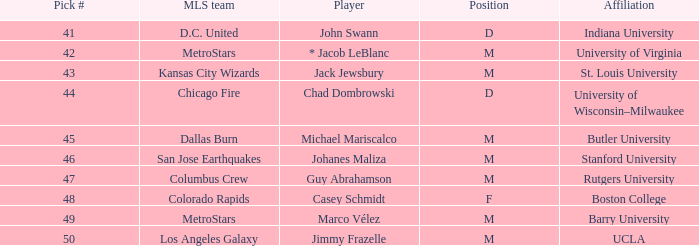Could you parse the entire table? {'header': ['Pick #', 'MLS team', 'Player', 'Position', 'Affiliation'], 'rows': [['41', 'D.C. United', 'John Swann', 'D', 'Indiana University'], ['42', 'MetroStars', '* Jacob LeBlanc', 'M', 'University of Virginia'], ['43', 'Kansas City Wizards', 'Jack Jewsbury', 'M', 'St. Louis University'], ['44', 'Chicago Fire', 'Chad Dombrowski', 'D', 'University of Wisconsin–Milwaukee'], ['45', 'Dallas Burn', 'Michael Mariscalco', 'M', 'Butler University'], ['46', 'San Jose Earthquakes', 'Johanes Maliza', 'M', 'Stanford University'], ['47', 'Columbus Crew', 'Guy Abrahamson', 'M', 'Rutgers University'], ['48', 'Colorado Rapids', 'Casey Schmidt', 'F', 'Boston College'], ['49', 'MetroStars', 'Marco Vélez', 'M', 'Barry University'], ['50', 'Los Angeles Galaxy', 'Jimmy Frazelle', 'M', 'UCLA']]} What team does Jimmy Frazelle play on? Los Angeles Galaxy. 